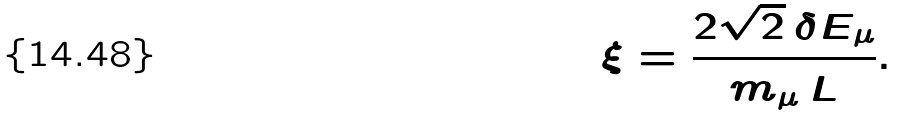<formula> <loc_0><loc_0><loc_500><loc_500>\xi = \frac { 2 \sqrt { 2 } \, \delta E _ { \mu } } { m _ { \mu } \, L } .</formula> 